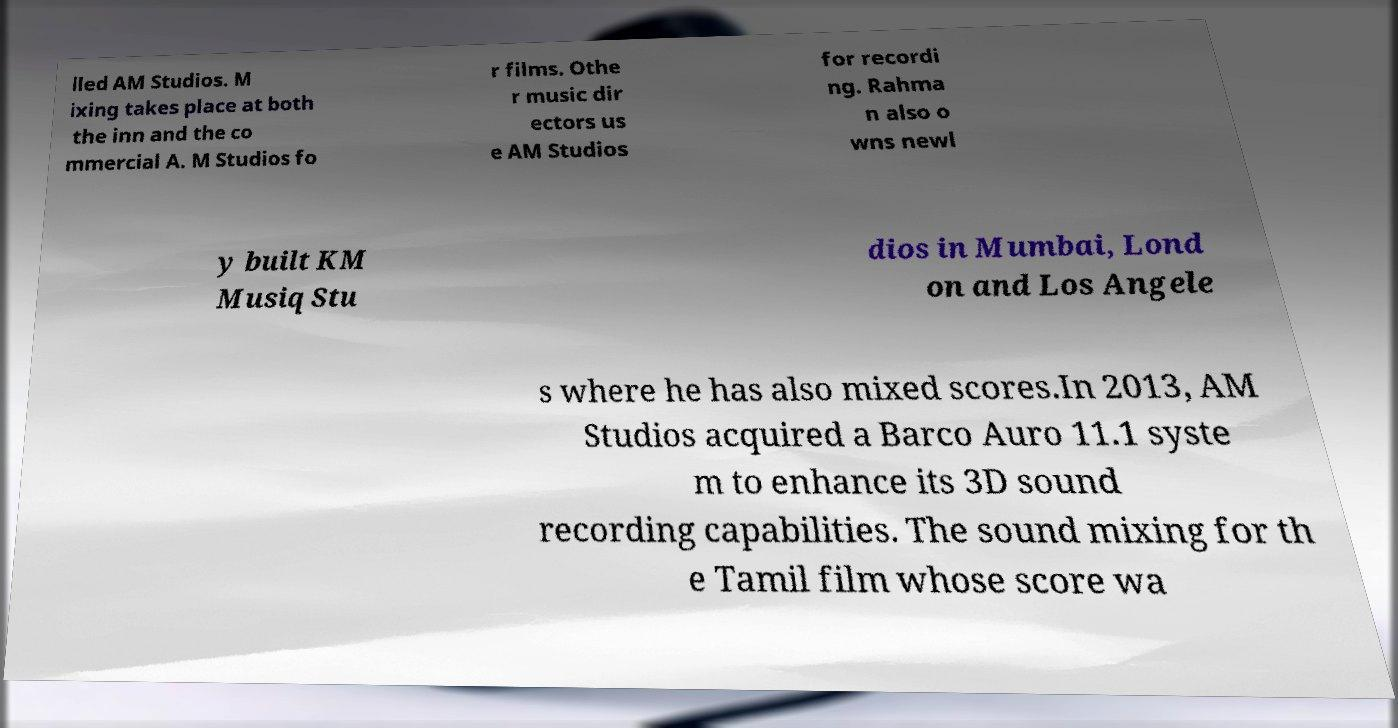Could you extract and type out the text from this image? lled AM Studios. M ixing takes place at both the inn and the co mmercial A. M Studios fo r films. Othe r music dir ectors us e AM Studios for recordi ng. Rahma n also o wns newl y built KM Musiq Stu dios in Mumbai, Lond on and Los Angele s where he has also mixed scores.In 2013, AM Studios acquired a Barco Auro 11.1 syste m to enhance its 3D sound recording capabilities. The sound mixing for th e Tamil film whose score wa 